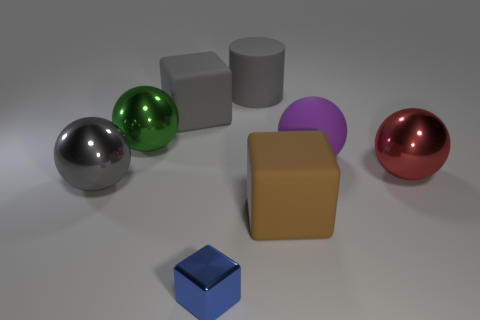Add 1 small green matte balls. How many objects exist? 9 Subtract all blocks. How many objects are left? 5 Add 8 rubber balls. How many rubber balls exist? 9 Subtract 0 blue balls. How many objects are left? 8 Subtract all brown matte cubes. Subtract all purple rubber objects. How many objects are left? 6 Add 5 cylinders. How many cylinders are left? 6 